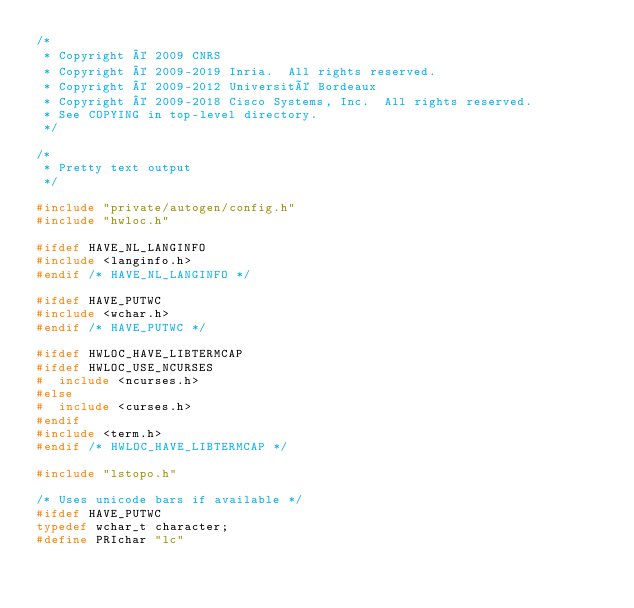Convert code to text. <code><loc_0><loc_0><loc_500><loc_500><_C_>/*
 * Copyright © 2009 CNRS
 * Copyright © 2009-2019 Inria.  All rights reserved.
 * Copyright © 2009-2012 Université Bordeaux
 * Copyright © 2009-2018 Cisco Systems, Inc.  All rights reserved.
 * See COPYING in top-level directory.
 */

/*
 * Pretty text output
 */

#include "private/autogen/config.h"
#include "hwloc.h"

#ifdef HAVE_NL_LANGINFO
#include <langinfo.h>
#endif /* HAVE_NL_LANGINFO */

#ifdef HAVE_PUTWC
#include <wchar.h>
#endif /* HAVE_PUTWC */

#ifdef HWLOC_HAVE_LIBTERMCAP
#ifdef HWLOC_USE_NCURSES
#  include <ncurses.h>
#else
#  include <curses.h>
#endif
#include <term.h>
#endif /* HWLOC_HAVE_LIBTERMCAP */

#include "lstopo.h"

/* Uses unicode bars if available */
#ifdef HAVE_PUTWC
typedef wchar_t character;
#define PRIchar "lc"</code> 